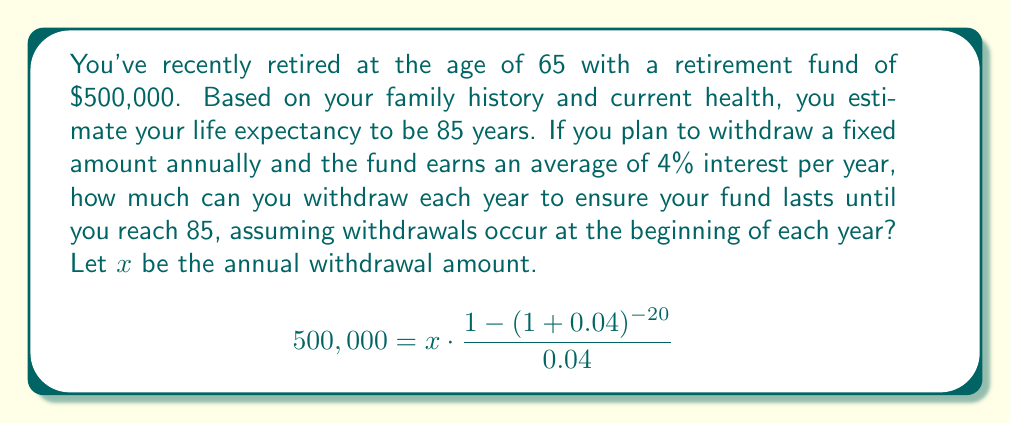Can you answer this question? To solve this problem, we'll use the present value of an annuity formula:

$$PV = PMT \cdot \frac{1-(1+r)^{-n}}{r}$$

Where:
$PV$ = Present Value (initial retirement fund)
$PMT$ = Payment (annual withdrawal)
$r$ = Interest rate
$n$ = Number of years

Given:
$PV = \$500,000$
$r = 4\% = 0.04$
$n = 85 - 65 = 20$ years

Let $x$ be the annual withdrawal amount (PMT).

Substituting these values into the formula:

$$500,000 = x \cdot \frac{1-(1+0.04)^{-20}}{0.04}$$

To solve for $x$, we first calculate the right-hand side of the fraction:

$$\frac{1-(1+0.04)^{-20}}{0.04} = \frac{1-0.4563}{0.04} = 13.5903$$

Now our equation becomes:

$$500,000 = x \cdot 13.5903$$

Solving for $x$:

$$x = \frac{500,000}{13.5903} = 36,791.55$$

Therefore, the annual withdrawal amount should be approximately $36,791.55.
Answer: $36,791.55 per year 